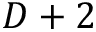Convert formula to latex. <formula><loc_0><loc_0><loc_500><loc_500>D + 2</formula> 